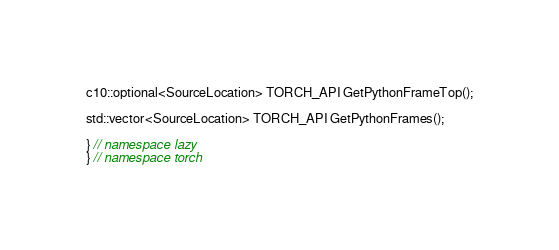Convert code to text. <code><loc_0><loc_0><loc_500><loc_500><_C_>
c10::optional<SourceLocation> TORCH_API GetPythonFrameTop();

std::vector<SourceLocation> TORCH_API GetPythonFrames();

} // namespace lazy
} // namespace torch
</code> 